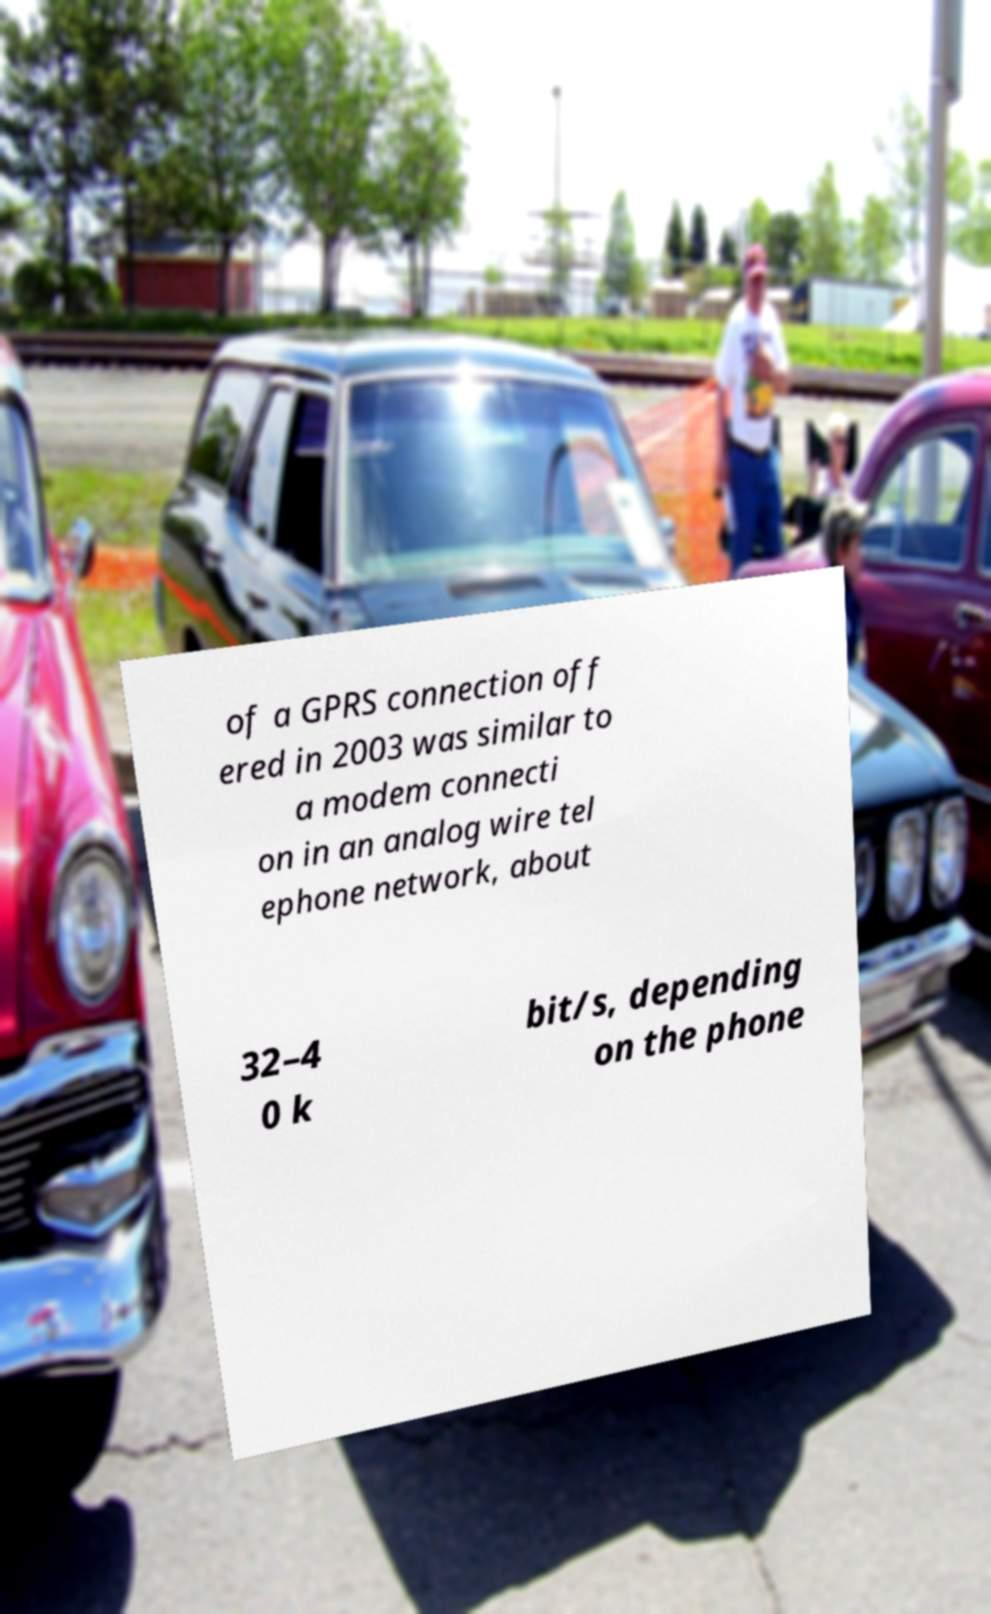Please read and relay the text visible in this image. What does it say? of a GPRS connection off ered in 2003 was similar to a modem connecti on in an analog wire tel ephone network, about 32–4 0 k bit/s, depending on the phone 